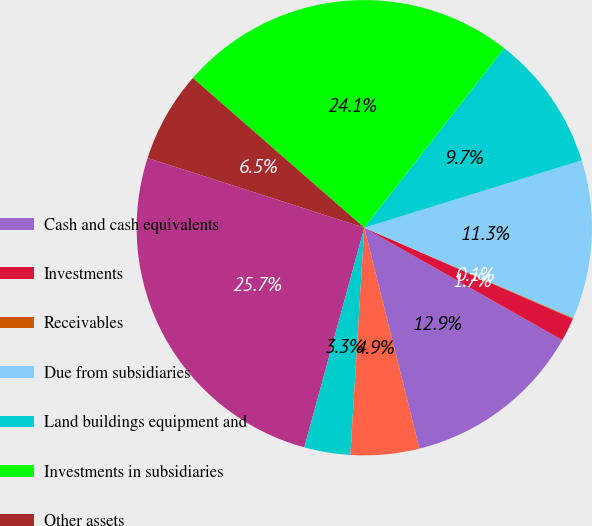<chart> <loc_0><loc_0><loc_500><loc_500><pie_chart><fcel>Cash and cash equivalents<fcel>Investments<fcel>Receivables<fcel>Due from subsidiaries<fcel>Land buildings equipment and<fcel>Investments in subsidiaries<fcel>Other assets<fcel>Total assets<fcel>Accounts payable and accrued<fcel>Due to subsidiaries<nl><fcel>12.89%<fcel>1.66%<fcel>0.06%<fcel>11.28%<fcel>9.68%<fcel>24.11%<fcel>6.47%<fcel>25.71%<fcel>3.27%<fcel>4.87%<nl></chart> 